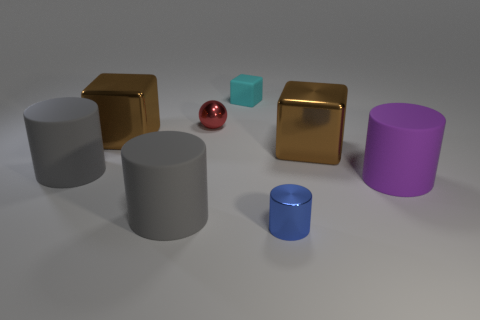Add 2 gray matte objects. How many objects exist? 10 Subtract all balls. How many objects are left? 7 Subtract all tiny blue metal objects. Subtract all small objects. How many objects are left? 4 Add 5 small cyan cubes. How many small cyan cubes are left? 6 Add 4 large brown cubes. How many large brown cubes exist? 6 Subtract 0 yellow cylinders. How many objects are left? 8 